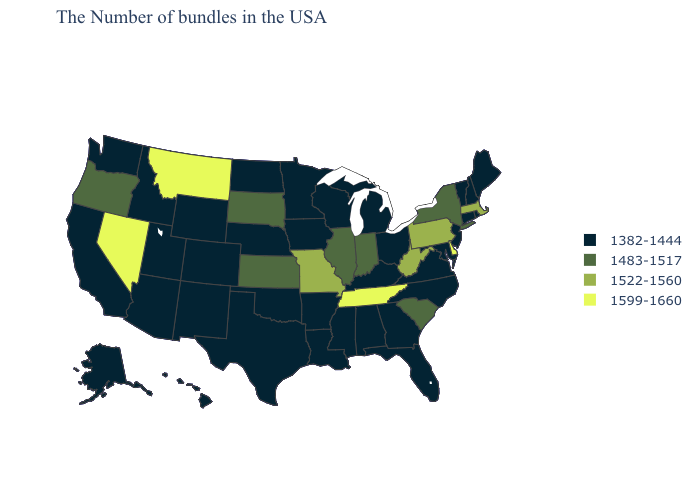What is the value of Texas?
Short answer required. 1382-1444. Which states have the lowest value in the West?
Give a very brief answer. Wyoming, Colorado, New Mexico, Utah, Arizona, Idaho, California, Washington, Alaska, Hawaii. Which states hav the highest value in the Northeast?
Quick response, please. Massachusetts, Pennsylvania. Which states have the lowest value in the West?
Write a very short answer. Wyoming, Colorado, New Mexico, Utah, Arizona, Idaho, California, Washington, Alaska, Hawaii. Among the states that border California , does Arizona have the highest value?
Write a very short answer. No. Which states have the lowest value in the USA?
Write a very short answer. Maine, Rhode Island, New Hampshire, Vermont, Connecticut, New Jersey, Maryland, Virginia, North Carolina, Ohio, Florida, Georgia, Michigan, Kentucky, Alabama, Wisconsin, Mississippi, Louisiana, Arkansas, Minnesota, Iowa, Nebraska, Oklahoma, Texas, North Dakota, Wyoming, Colorado, New Mexico, Utah, Arizona, Idaho, California, Washington, Alaska, Hawaii. Name the states that have a value in the range 1483-1517?
Be succinct. New York, South Carolina, Indiana, Illinois, Kansas, South Dakota, Oregon. Among the states that border Arizona , which have the highest value?
Be succinct. Nevada. Name the states that have a value in the range 1483-1517?
Answer briefly. New York, South Carolina, Indiana, Illinois, Kansas, South Dakota, Oregon. Name the states that have a value in the range 1483-1517?
Give a very brief answer. New York, South Carolina, Indiana, Illinois, Kansas, South Dakota, Oregon. What is the value of Indiana?
Give a very brief answer. 1483-1517. What is the value of North Dakota?
Be succinct. 1382-1444. What is the value of California?
Answer briefly. 1382-1444. Name the states that have a value in the range 1522-1560?
Be succinct. Massachusetts, Pennsylvania, West Virginia, Missouri. Name the states that have a value in the range 1522-1560?
Give a very brief answer. Massachusetts, Pennsylvania, West Virginia, Missouri. 